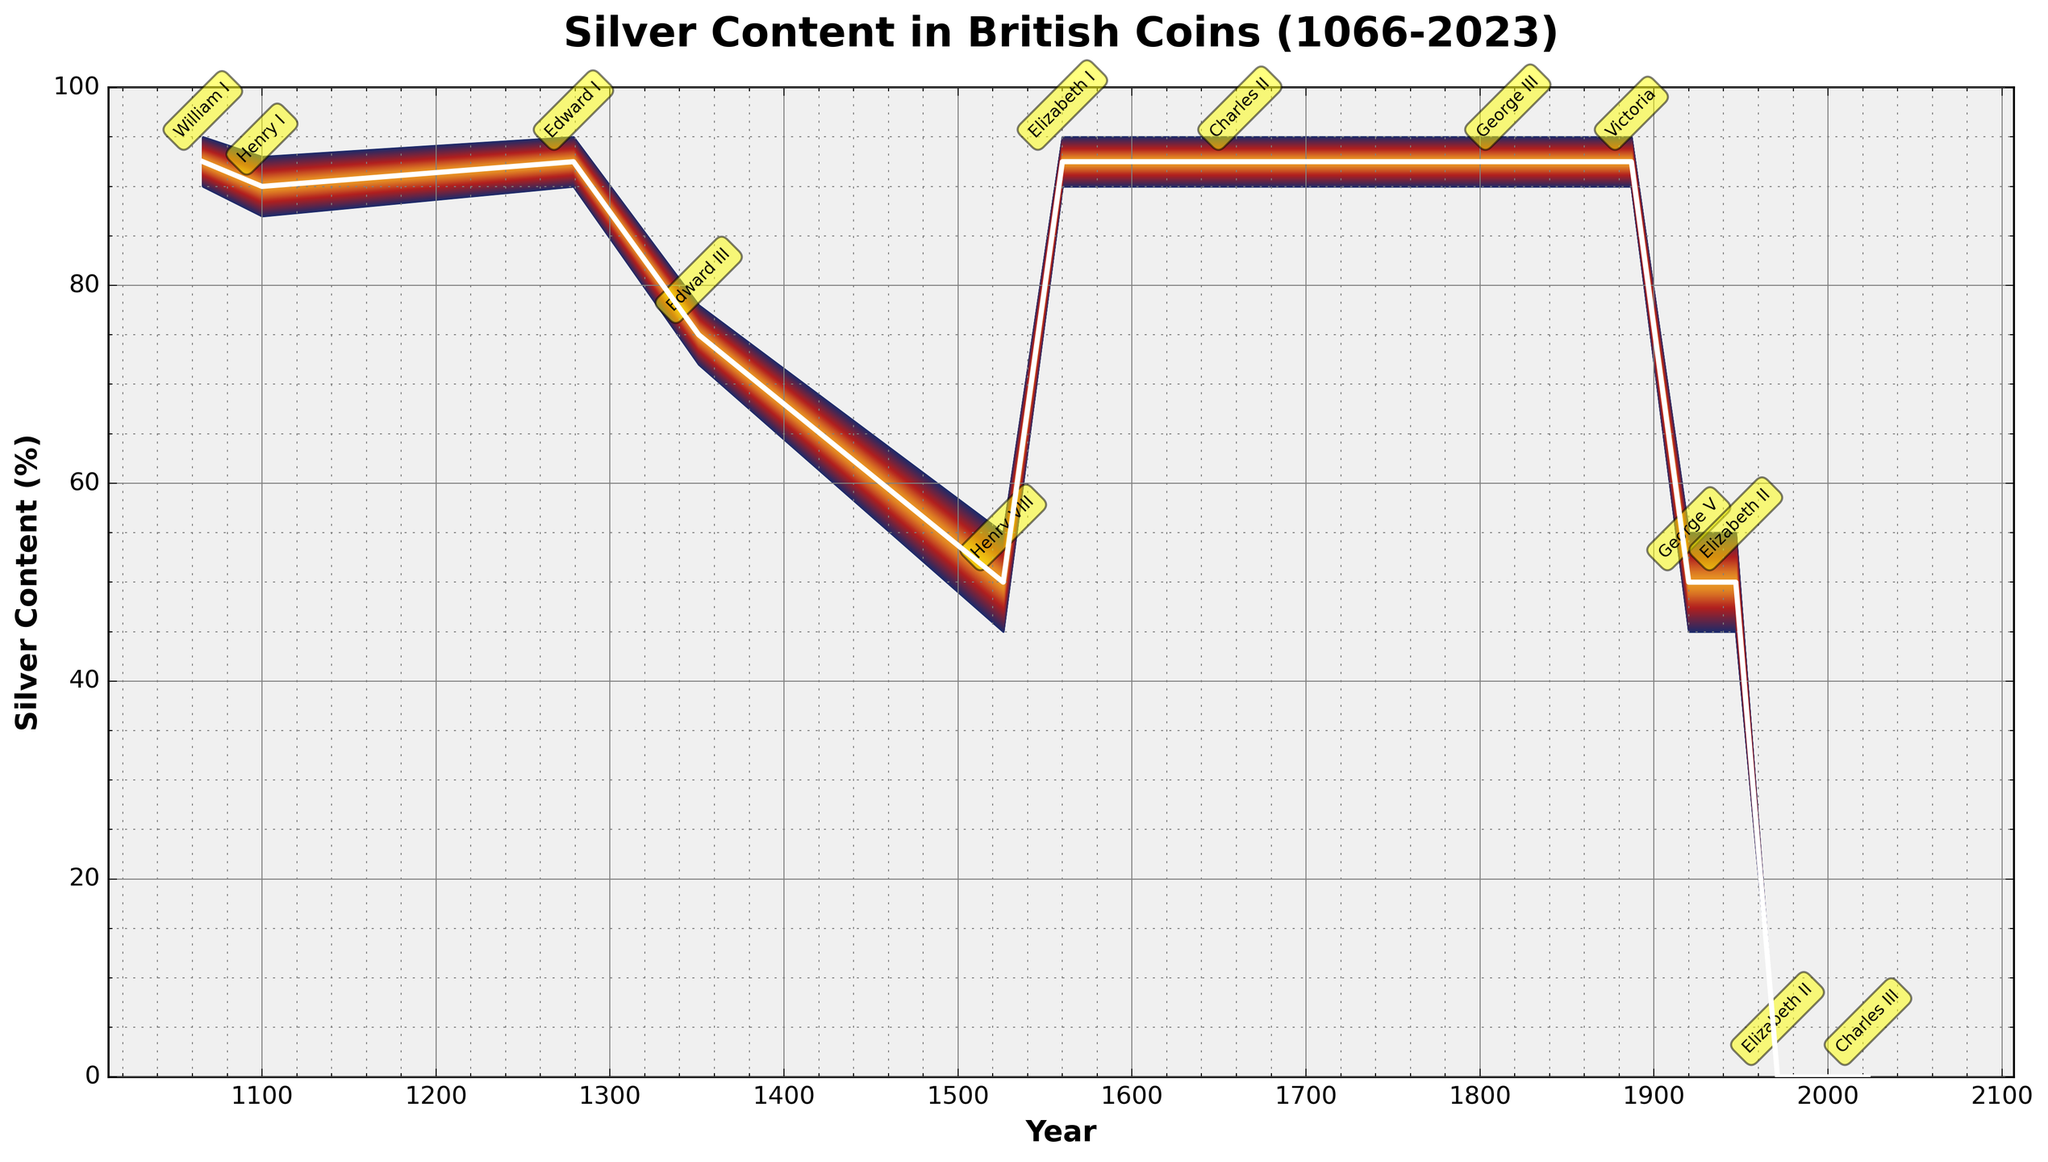What is the title of the figure? The title of the figure is located at the top of the chart. It provides a summary of what the chart represents.
Answer: Silver Content in British Coins (1066-2023) What does the y-axis of the figure represent? The y-axis represents the silver content in the coins, expressed as a percentage. You can observe this by noting the label on the y-axis.
Answer: Silver Content (%) How many data points are represented on the chart? Each monarch's reign is represented by a single data point that shows their respective years and silver content. Counting these points gives the total number.
Answer: 13 What is the silver content percentage during the reign of Edward III? Locate the data point labeled "Edward III" on the chart, then check its corresponding y-axis value for the silver content.
Answer: 75% How did the silver content change from the reign of Henry VIII to Elizabeth I? To determine this, find the silver content values of both Henry VIII and Elizabeth I and then compare these values. The silver content increased from Henry VIII's reign to Elizabeth I's reign.
Answer: Increased from 50% to 92.5% During which monarch's reign did the silver content of coins drop to zero for the first time? Look for the point where the y-value (silver content) first reaches zero and identify the corresponding monarch.
Answer: Elizabeth II Which monarchs maintained a constant high level of silver content in coins? Identify monarchs who had a silver content of around 92.5% throughout their reign without significant fluctuations, referring to the associated dates and points.
Answer: William I, Edward I, Elizabeth I, Charles II, George III, Victoria By how much did the lower bound of silver content increase from Henry VIII's reign to Elizabeth I's reign? Calculate the difference between the lower bounds during these reigns by looking at the respective bottom error range values. The lower bound increased.
Answer: Increased by 45% Which reigns show a significant fluctuation in the silver content between their lower and upper bounds? Identify monarchs whose error ranges (distance between lower and upper bounds) are notably large.
Answer: Henry VIII, George V, Elizabeth II (1920-1947) What is the difference in silver content between the reigns of Edward III and Henry VIII? Subtract the silver content during Henry VIII's reign from that of Edward III's to find the difference.
Answer: -25% (75% to 50%) 